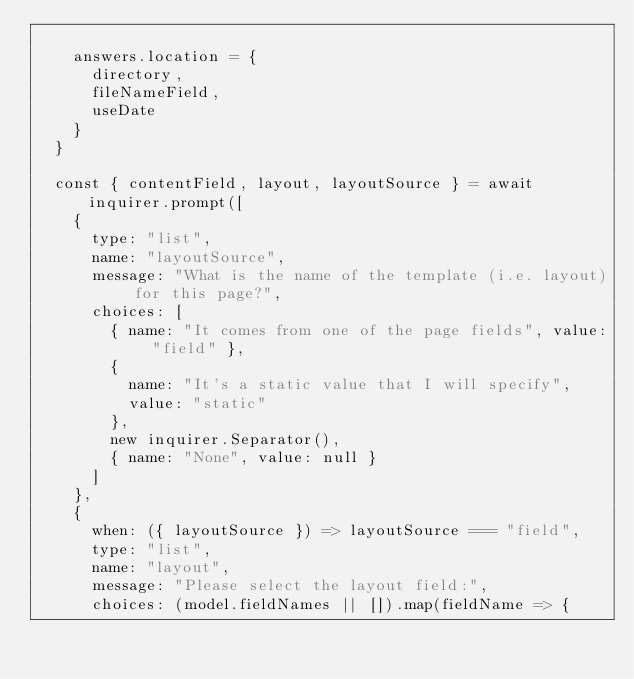Convert code to text. <code><loc_0><loc_0><loc_500><loc_500><_JavaScript_>
    answers.location = {
      directory,
      fileNameField,
      useDate
    }
  }

  const { contentField, layout, layoutSource } = await inquirer.prompt([
    {
      type: "list",
      name: "layoutSource",
      message: "What is the name of the template (i.e. layout) for this page?",
      choices: [
        { name: "It comes from one of the page fields", value: "field" },
        {
          name: "It's a static value that I will specify",
          value: "static"
        },
        new inquirer.Separator(),
        { name: "None", value: null }
      ]
    },
    {
      when: ({ layoutSource }) => layoutSource === "field",
      type: "list",
      name: "layout",
      message: "Please select the layout field:",
      choices: (model.fieldNames || []).map(fieldName => {</code> 